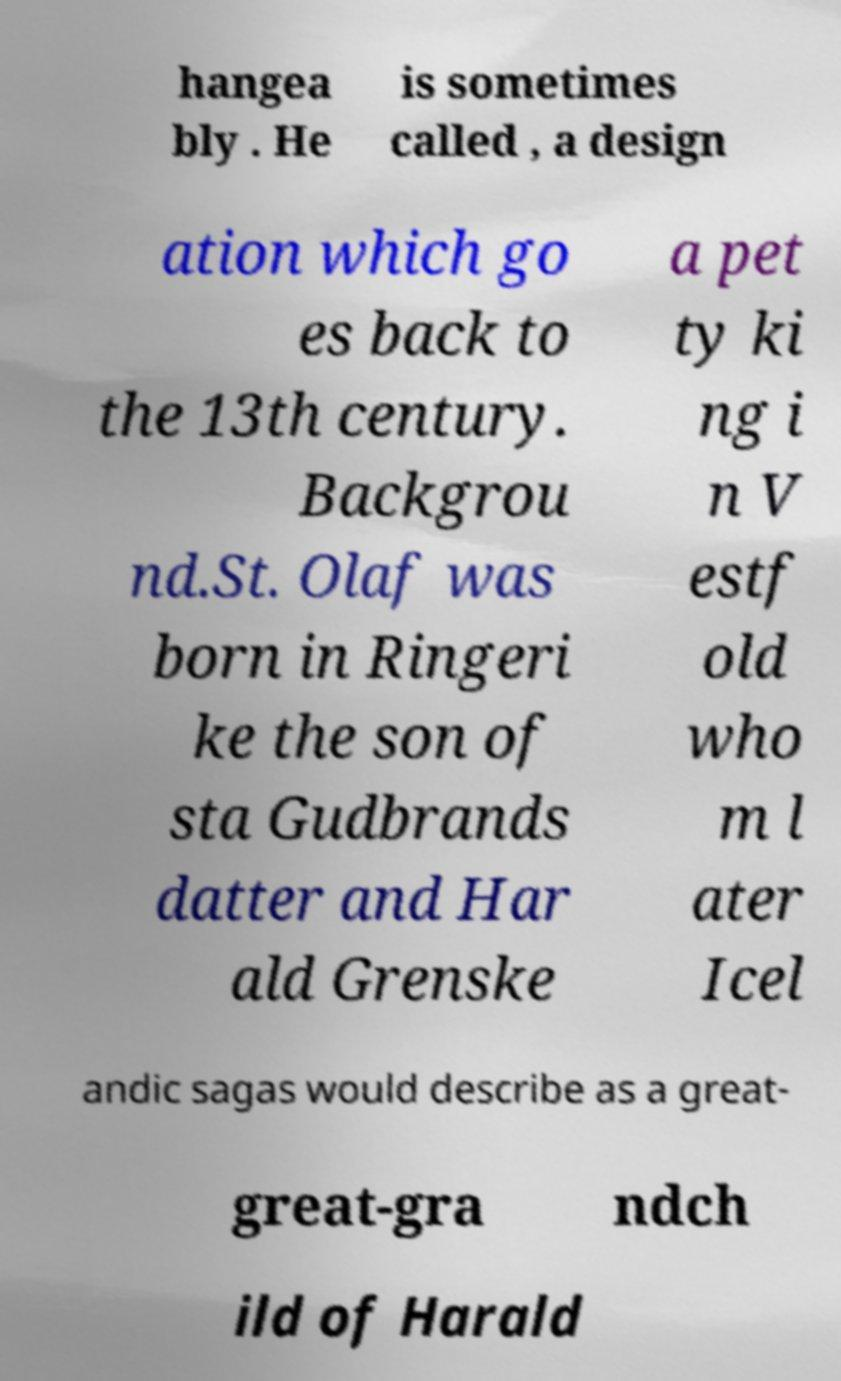For documentation purposes, I need the text within this image transcribed. Could you provide that? hangea bly . He is sometimes called , a design ation which go es back to the 13th century. Backgrou nd.St. Olaf was born in Ringeri ke the son of sta Gudbrands datter and Har ald Grenske a pet ty ki ng i n V estf old who m l ater Icel andic sagas would describe as a great- great-gra ndch ild of Harald 